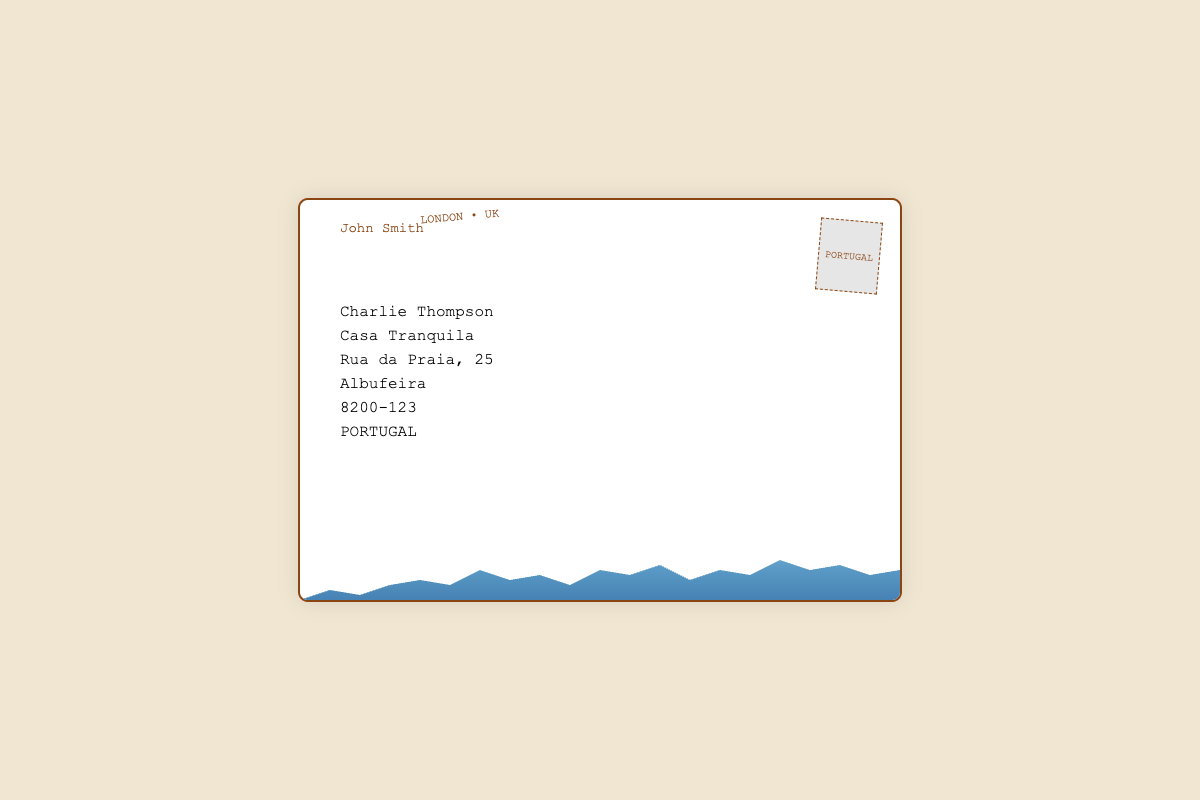What is the sender's name? The sender's name is displayed in the top section of the envelope.
Answer: John Smith What city is the postcard from? The postmark indicates the location from where the postcard was sent.
Answer: LONDON What is the recipient's address? The address details are mentioned clearly in the envelope section.
Answer: Casa Tranquila, Rua da Praia, 25, Albufeira, 8200-123, PORTUGAL What feature is included at the bottom of the envelope? The visual element at the bottom represents a recognizable feature of London.
Answer: The skyline What does the stamp indicate? The stamp shows the destination country where the postcard is sent.
Answer: PORTUGAL How many lines are in the recipient's address? Counting the address lines helps determine the details provided for the recipient.
Answer: 5 lines What color is the background of the envelope? The background color of the envelope is important for its visual appeal.
Answer: White What design element is used for the skyline? The visual appearance of the skyline is defined by its specific design.
Answer: Linear gradient with a clip-path What is the recipient's postal code? The postal code is provided to identify the recipient's location accurately.
Answer: 8200-123 